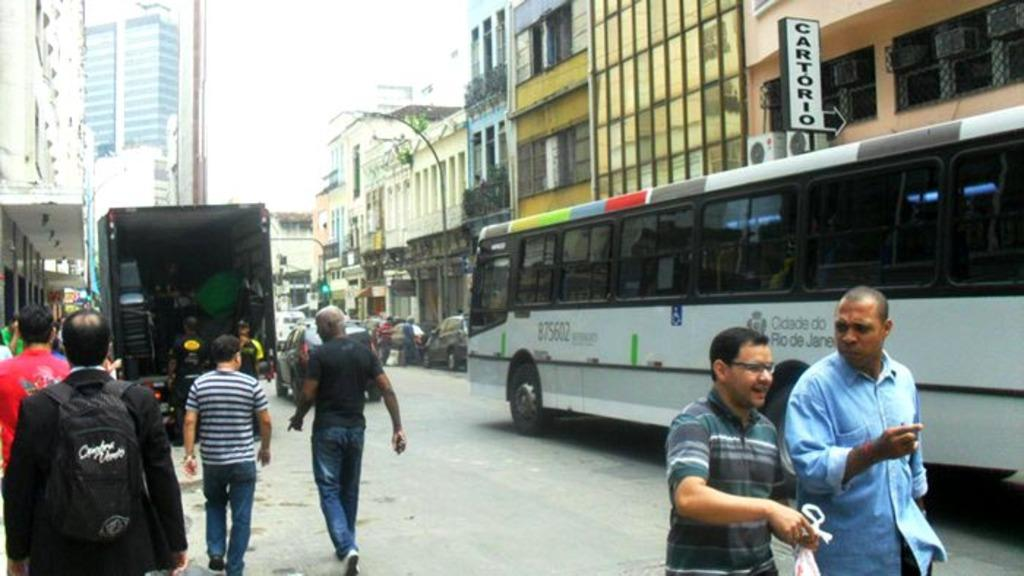<image>
Present a compact description of the photo's key features. People walk down the street next to a bus that says Cidade Do Rio De Janeiro on its side. 